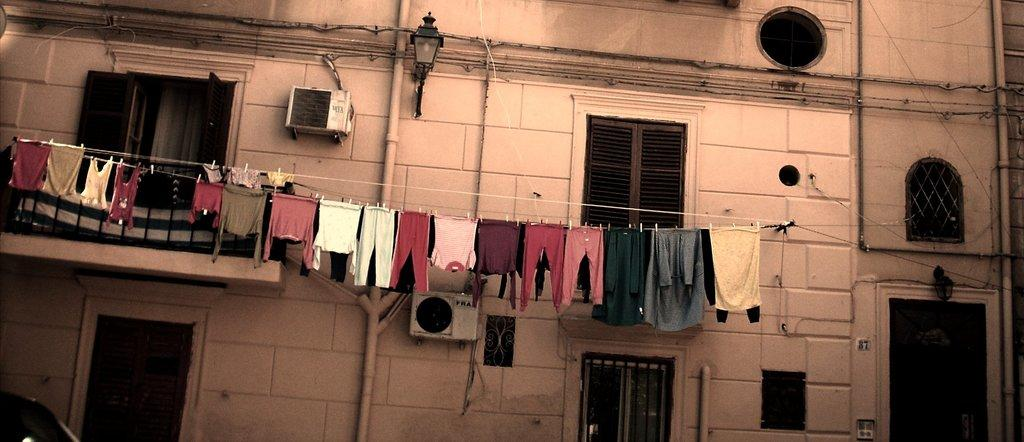What type of structure is present in the image? There is a building in the image. What features can be seen on the building? The building has doors and windows. What additional element is present in the image? There is a metal railing in the image. Can you describe the lighting in the image? There is a light in the image. What is hanging in the foreground of the image? Clothes are hanging on a rope in the foreground. What type of behavior can be observed in the clothes hanging on the rope? The clothes hanging on the rope are not exhibiting any behavior, as they are inanimate objects. 